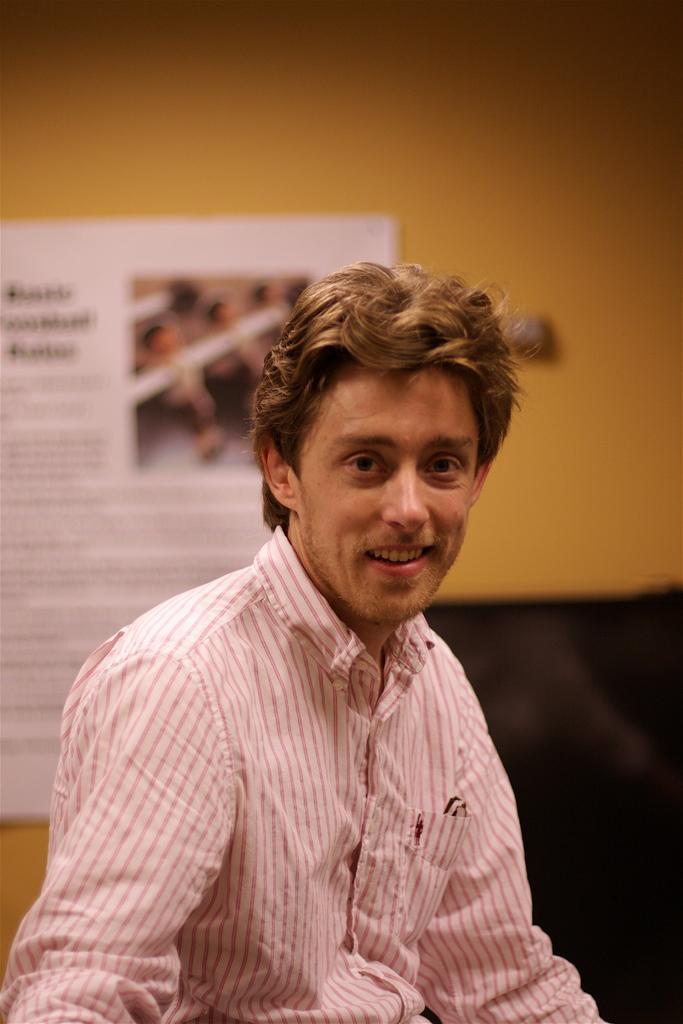Please provide a concise description of this image. This image is taken indoors. In the background there is a wall and there is a poster with a text and an image on it. In the middle of the image there is a man and he is with a smiling face. 